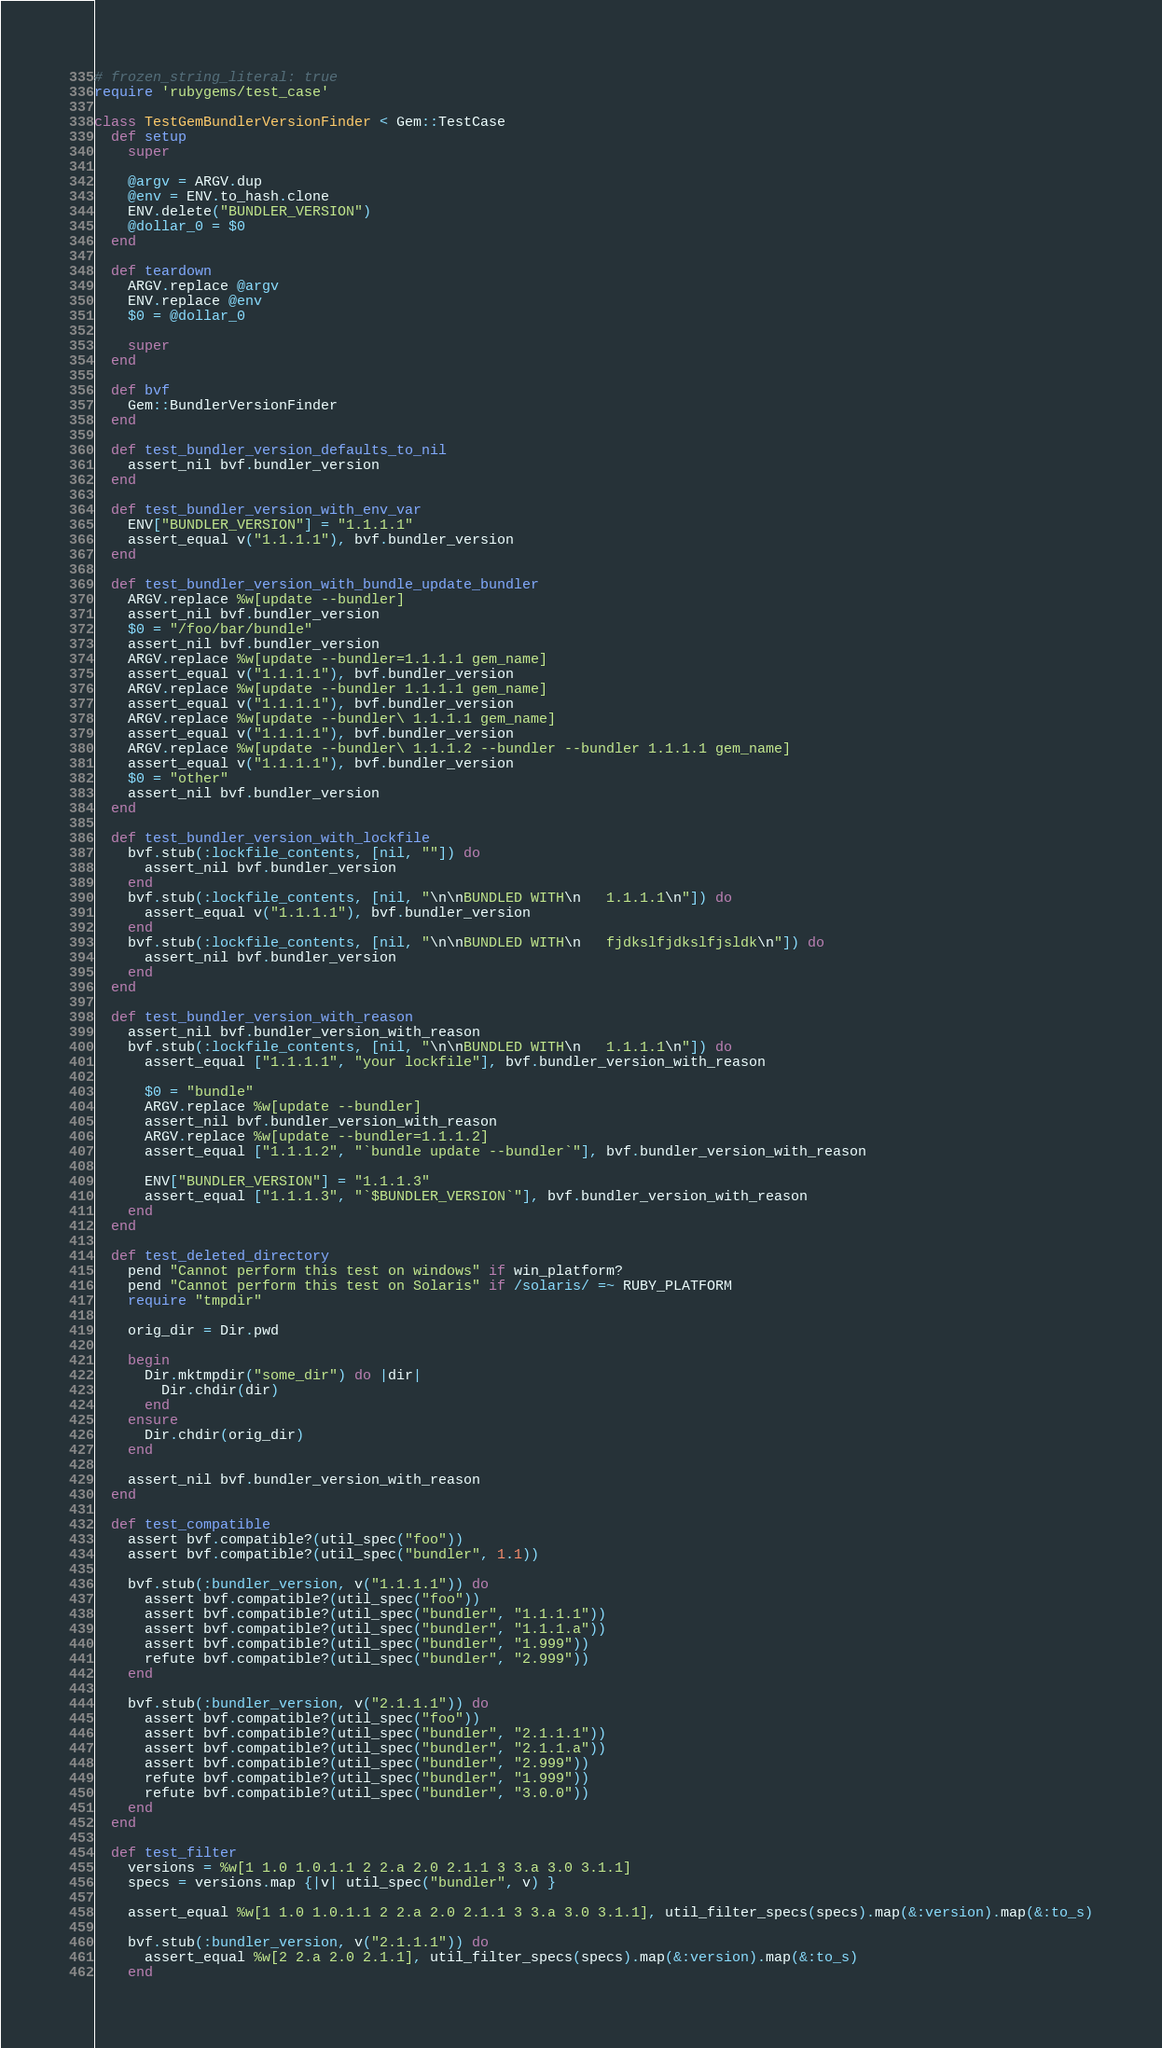Convert code to text. <code><loc_0><loc_0><loc_500><loc_500><_Ruby_># frozen_string_literal: true
require 'rubygems/test_case'

class TestGemBundlerVersionFinder < Gem::TestCase
  def setup
    super

    @argv = ARGV.dup
    @env = ENV.to_hash.clone
    ENV.delete("BUNDLER_VERSION")
    @dollar_0 = $0
  end

  def teardown
    ARGV.replace @argv
    ENV.replace @env
    $0 = @dollar_0

    super
  end

  def bvf
    Gem::BundlerVersionFinder
  end

  def test_bundler_version_defaults_to_nil
    assert_nil bvf.bundler_version
  end

  def test_bundler_version_with_env_var
    ENV["BUNDLER_VERSION"] = "1.1.1.1"
    assert_equal v("1.1.1.1"), bvf.bundler_version
  end

  def test_bundler_version_with_bundle_update_bundler
    ARGV.replace %w[update --bundler]
    assert_nil bvf.bundler_version
    $0 = "/foo/bar/bundle"
    assert_nil bvf.bundler_version
    ARGV.replace %w[update --bundler=1.1.1.1 gem_name]
    assert_equal v("1.1.1.1"), bvf.bundler_version
    ARGV.replace %w[update --bundler 1.1.1.1 gem_name]
    assert_equal v("1.1.1.1"), bvf.bundler_version
    ARGV.replace %w[update --bundler\ 1.1.1.1 gem_name]
    assert_equal v("1.1.1.1"), bvf.bundler_version
    ARGV.replace %w[update --bundler\ 1.1.1.2 --bundler --bundler 1.1.1.1 gem_name]
    assert_equal v("1.1.1.1"), bvf.bundler_version
    $0 = "other"
    assert_nil bvf.bundler_version
  end

  def test_bundler_version_with_lockfile
    bvf.stub(:lockfile_contents, [nil, ""]) do
      assert_nil bvf.bundler_version
    end
    bvf.stub(:lockfile_contents, [nil, "\n\nBUNDLED WITH\n   1.1.1.1\n"]) do
      assert_equal v("1.1.1.1"), bvf.bundler_version
    end
    bvf.stub(:lockfile_contents, [nil, "\n\nBUNDLED WITH\n   fjdkslfjdkslfjsldk\n"]) do
      assert_nil bvf.bundler_version
    end
  end

  def test_bundler_version_with_reason
    assert_nil bvf.bundler_version_with_reason
    bvf.stub(:lockfile_contents, [nil, "\n\nBUNDLED WITH\n   1.1.1.1\n"]) do
      assert_equal ["1.1.1.1", "your lockfile"], bvf.bundler_version_with_reason

      $0 = "bundle"
      ARGV.replace %w[update --bundler]
      assert_nil bvf.bundler_version_with_reason
      ARGV.replace %w[update --bundler=1.1.1.2]
      assert_equal ["1.1.1.2", "`bundle update --bundler`"], bvf.bundler_version_with_reason

      ENV["BUNDLER_VERSION"] = "1.1.1.3"
      assert_equal ["1.1.1.3", "`$BUNDLER_VERSION`"], bvf.bundler_version_with_reason
    end
  end

  def test_deleted_directory
    pend "Cannot perform this test on windows" if win_platform?
    pend "Cannot perform this test on Solaris" if /solaris/ =~ RUBY_PLATFORM
    require "tmpdir"

    orig_dir = Dir.pwd

    begin
      Dir.mktmpdir("some_dir") do |dir|
        Dir.chdir(dir)
      end
    ensure
      Dir.chdir(orig_dir)
    end

    assert_nil bvf.bundler_version_with_reason
  end

  def test_compatible
    assert bvf.compatible?(util_spec("foo"))
    assert bvf.compatible?(util_spec("bundler", 1.1))

    bvf.stub(:bundler_version, v("1.1.1.1")) do
      assert bvf.compatible?(util_spec("foo"))
      assert bvf.compatible?(util_spec("bundler", "1.1.1.1"))
      assert bvf.compatible?(util_spec("bundler", "1.1.1.a"))
      assert bvf.compatible?(util_spec("bundler", "1.999"))
      refute bvf.compatible?(util_spec("bundler", "2.999"))
    end

    bvf.stub(:bundler_version, v("2.1.1.1")) do
      assert bvf.compatible?(util_spec("foo"))
      assert bvf.compatible?(util_spec("bundler", "2.1.1.1"))
      assert bvf.compatible?(util_spec("bundler", "2.1.1.a"))
      assert bvf.compatible?(util_spec("bundler", "2.999"))
      refute bvf.compatible?(util_spec("bundler", "1.999"))
      refute bvf.compatible?(util_spec("bundler", "3.0.0"))
    end
  end

  def test_filter
    versions = %w[1 1.0 1.0.1.1 2 2.a 2.0 2.1.1 3 3.a 3.0 3.1.1]
    specs = versions.map {|v| util_spec("bundler", v) }

    assert_equal %w[1 1.0 1.0.1.1 2 2.a 2.0 2.1.1 3 3.a 3.0 3.1.1], util_filter_specs(specs).map(&:version).map(&:to_s)

    bvf.stub(:bundler_version, v("2.1.1.1")) do
      assert_equal %w[2 2.a 2.0 2.1.1], util_filter_specs(specs).map(&:version).map(&:to_s)
    end</code> 